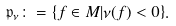Convert formula to latex. <formula><loc_0><loc_0><loc_500><loc_500>\mathfrak { p } _ { \nu } \colon = \{ f \in M | \nu ( f ) < 0 \} .</formula> 